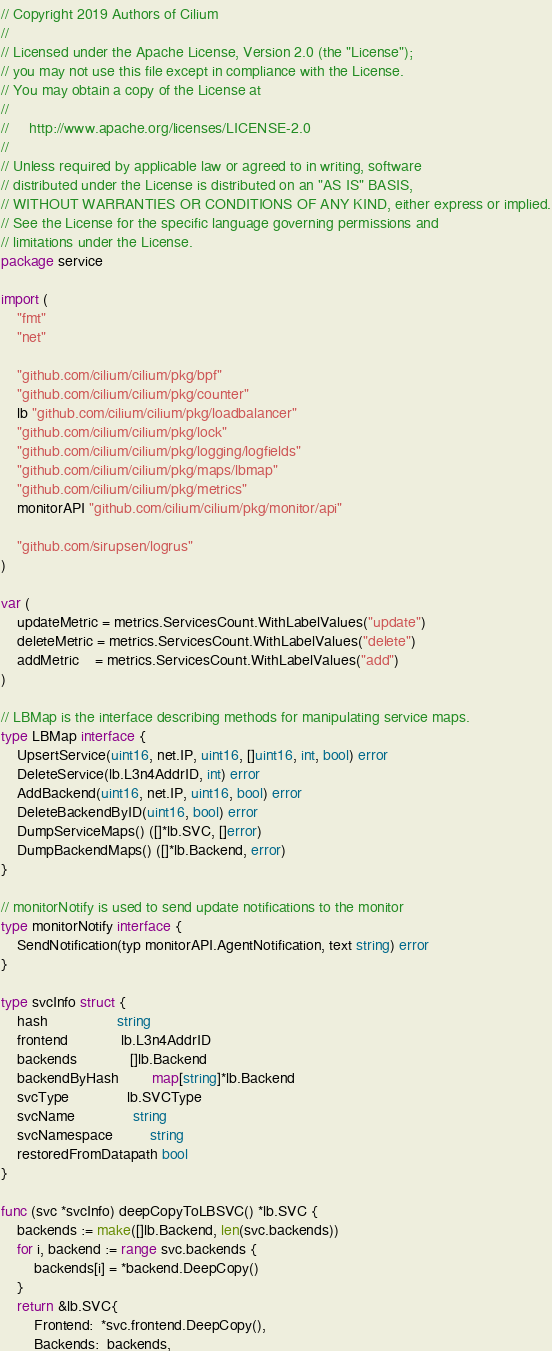<code> <loc_0><loc_0><loc_500><loc_500><_Go_>// Copyright 2019 Authors of Cilium
//
// Licensed under the Apache License, Version 2.0 (the "License");
// you may not use this file except in compliance with the License.
// You may obtain a copy of the License at
//
//     http://www.apache.org/licenses/LICENSE-2.0
//
// Unless required by applicable law or agreed to in writing, software
// distributed under the License is distributed on an "AS IS" BASIS,
// WITHOUT WARRANTIES OR CONDITIONS OF ANY KIND, either express or implied.
// See the License for the specific language governing permissions and
// limitations under the License.
package service

import (
	"fmt"
	"net"

	"github.com/cilium/cilium/pkg/bpf"
	"github.com/cilium/cilium/pkg/counter"
	lb "github.com/cilium/cilium/pkg/loadbalancer"
	"github.com/cilium/cilium/pkg/lock"
	"github.com/cilium/cilium/pkg/logging/logfields"
	"github.com/cilium/cilium/pkg/maps/lbmap"
	"github.com/cilium/cilium/pkg/metrics"
	monitorAPI "github.com/cilium/cilium/pkg/monitor/api"

	"github.com/sirupsen/logrus"
)

var (
	updateMetric = metrics.ServicesCount.WithLabelValues("update")
	deleteMetric = metrics.ServicesCount.WithLabelValues("delete")
	addMetric    = metrics.ServicesCount.WithLabelValues("add")
)

// LBMap is the interface describing methods for manipulating service maps.
type LBMap interface {
	UpsertService(uint16, net.IP, uint16, []uint16, int, bool) error
	DeleteService(lb.L3n4AddrID, int) error
	AddBackend(uint16, net.IP, uint16, bool) error
	DeleteBackendByID(uint16, bool) error
	DumpServiceMaps() ([]*lb.SVC, []error)
	DumpBackendMaps() ([]*lb.Backend, error)
}

// monitorNotify is used to send update notifications to the monitor
type monitorNotify interface {
	SendNotification(typ monitorAPI.AgentNotification, text string) error
}

type svcInfo struct {
	hash                 string
	frontend             lb.L3n4AddrID
	backends             []lb.Backend
	backendByHash        map[string]*lb.Backend
	svcType              lb.SVCType
	svcName              string
	svcNamespace         string
	restoredFromDatapath bool
}

func (svc *svcInfo) deepCopyToLBSVC() *lb.SVC {
	backends := make([]lb.Backend, len(svc.backends))
	for i, backend := range svc.backends {
		backends[i] = *backend.DeepCopy()
	}
	return &lb.SVC{
		Frontend:  *svc.frontend.DeepCopy(),
		Backends:  backends,</code> 